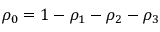<formula> <loc_0><loc_0><loc_500><loc_500>\rho _ { 0 } = 1 - \rho _ { 1 } - \rho _ { 2 } - \rho _ { 3 }</formula> 